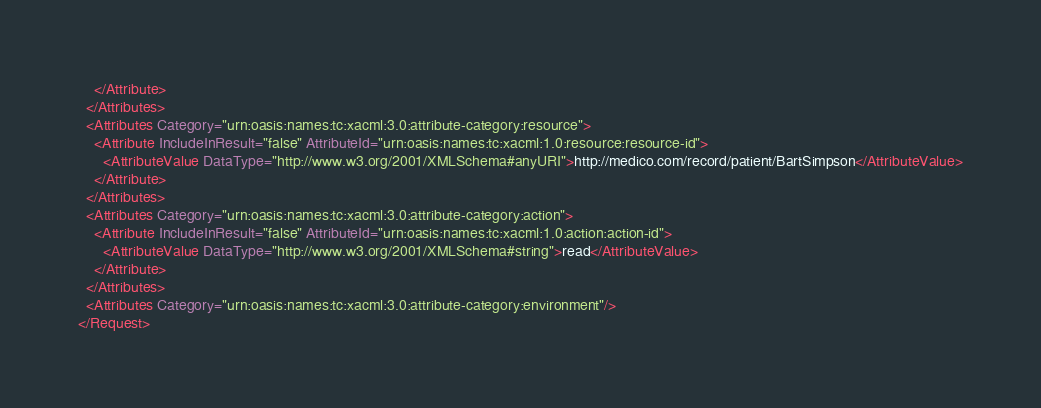Convert code to text. <code><loc_0><loc_0><loc_500><loc_500><_XML_>    </Attribute>
  </Attributes>
  <Attributes Category="urn:oasis:names:tc:xacml:3.0:attribute-category:resource">
    <Attribute IncludeInResult="false" AttributeId="urn:oasis:names:tc:xacml:1.0:resource:resource-id">
      <AttributeValue DataType="http://www.w3.org/2001/XMLSchema#anyURI">http://medico.com/record/patient/BartSimpson</AttributeValue>
    </Attribute>
  </Attributes>
  <Attributes Category="urn:oasis:names:tc:xacml:3.0:attribute-category:action">
    <Attribute IncludeInResult="false" AttributeId="urn:oasis:names:tc:xacml:1.0:action:action-id">
      <AttributeValue DataType="http://www.w3.org/2001/XMLSchema#string">read</AttributeValue>
    </Attribute>
  </Attributes>
  <Attributes Category="urn:oasis:names:tc:xacml:3.0:attribute-category:environment"/>
</Request>
</code> 